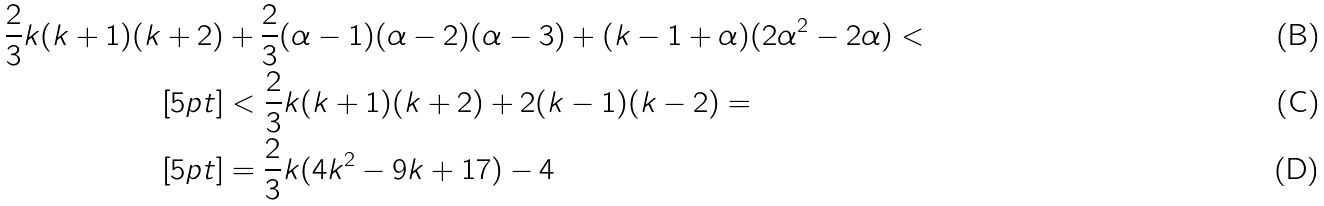<formula> <loc_0><loc_0><loc_500><loc_500>\frac { 2 } { 3 } k ( k + 1 ) ( k + 2 ) & + \frac { 2 } { 3 } ( \alpha - 1 ) ( \alpha - 2 ) ( \alpha - 3 ) + ( k - 1 + \alpha ) ( 2 \alpha ^ { 2 } - 2 \alpha ) < \\ [ 5 p t ] & < \frac { 2 } { 3 } k ( k + 1 ) ( k + 2 ) + 2 ( k - 1 ) ( k - 2 ) = \\ [ 5 p t ] & = \frac { 2 } { 3 } k ( 4 k ^ { 2 } - 9 k + 1 7 ) - 4</formula> 